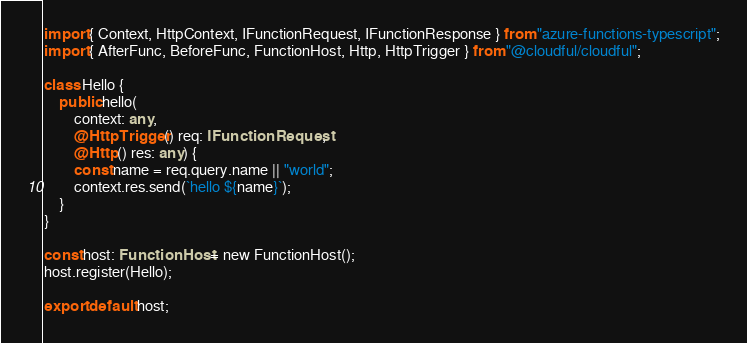<code> <loc_0><loc_0><loc_500><loc_500><_TypeScript_>import { Context, HttpContext, IFunctionRequest, IFunctionResponse } from "azure-functions-typescript";
import { AfterFunc, BeforeFunc, FunctionHost, Http, HttpTrigger } from "@cloudful/cloudful";

class Hello {
    public hello(
        context: any,
        @HttpTrigger() req: IFunctionRequest,
        @Http() res: any) {
        const name = req.query.name || "world";
        context.res.send(`hello ${name}`);
    }
}

const host: FunctionHost = new FunctionHost();
host.register(Hello);

export default host;
</code> 